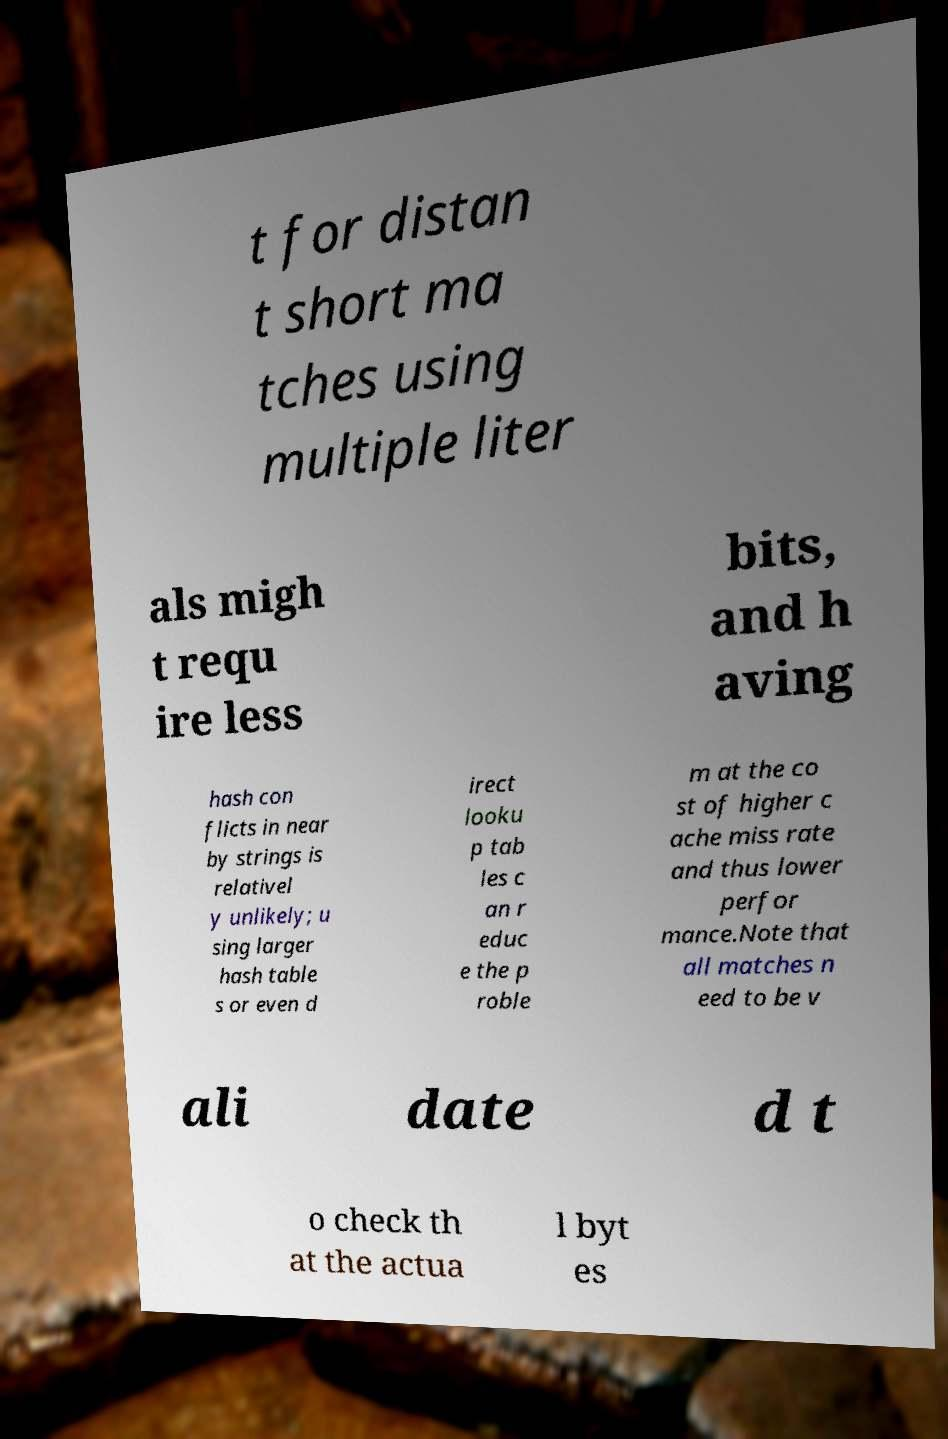Please read and relay the text visible in this image. What does it say? t for distan t short ma tches using multiple liter als migh t requ ire less bits, and h aving hash con flicts in near by strings is relativel y unlikely; u sing larger hash table s or even d irect looku p tab les c an r educ e the p roble m at the co st of higher c ache miss rate and thus lower perfor mance.Note that all matches n eed to be v ali date d t o check th at the actua l byt es 